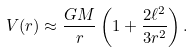<formula> <loc_0><loc_0><loc_500><loc_500>V ( r ) \approx \frac { G M } { r } \left ( 1 + \frac { 2 \ell ^ { 2 } } { 3 r ^ { 2 } } \right ) .</formula> 